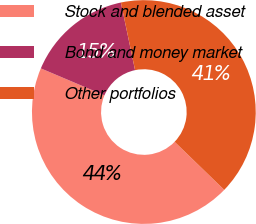<chart> <loc_0><loc_0><loc_500><loc_500><pie_chart><fcel>Stock and blended asset<fcel>Bond and money market<fcel>Other portfolios<nl><fcel>44.13%<fcel>15.33%<fcel>40.53%<nl></chart> 